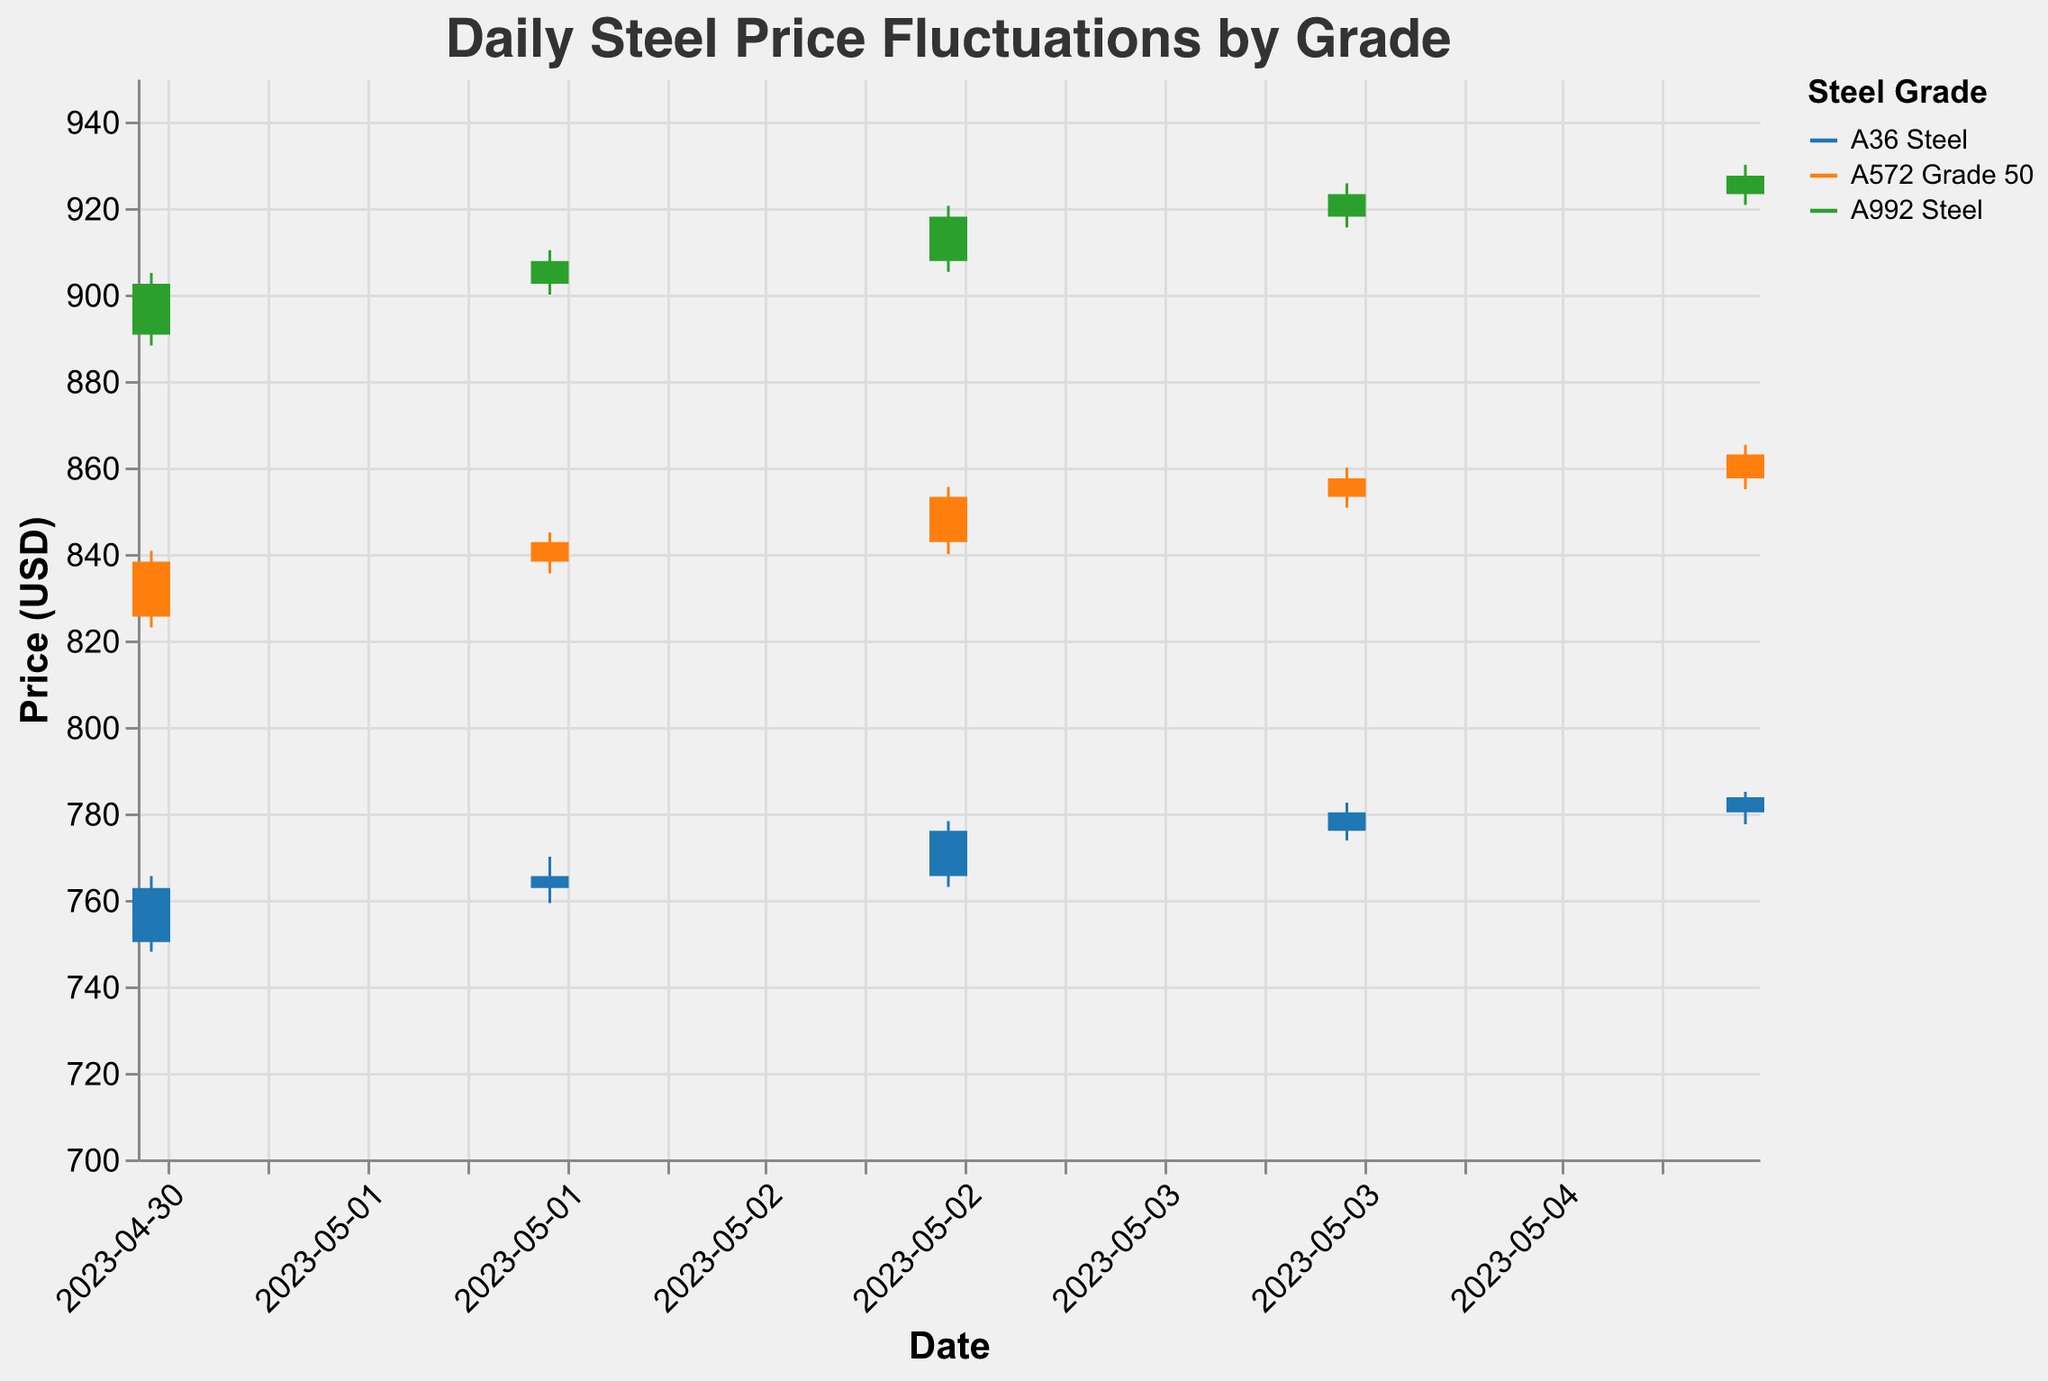What's the highest recorded price for A36 Steel? To find the highest recorded price for A36 Steel, we need to look at the "High" values for A36 Steel across all dates. The highest value for A36 Steel is 785.00 on May 05, 2023.
Answer: 785.00 Which grade of steel has the highest closing price on May 05, 2023? To find this, we need to compare the "Close" prices of all steel grades on May 05, 2023. For A36 Steel, it is 783.75; for A572 Grade 50, it is 863.00; and for A992 Steel, it is 927.50. The highest closing price is for A992 Steel.
Answer: A992 Steel What's the average closing price for A572 Grade 50 over the given dates? To find the average closing price, add the closing prices for A572 Grade 50 from May 01 to May 05: 838.25 + 842.75 + 853.25 + 857.50 + 863.00. Then, divide the sum by 5: (838.25 + 842.75 + 853.25 + 857.50 + 863.00) / 5 = 851.35
Answer: 851.35 Compare the opening price on May 01, 2023, to the closing price on May 05, 2023, for A36 Steel. Is it higher or lower? The opening price for A36 Steel on May 01, 2023, is 750.25, and the closing price on May 05, 2023, is 783.75. Since 783.75 is greater than 750.25, the closing price on May 05, 2023, is higher.
Answer: Higher Which day did A992 Steel have the smallest price fluctuation? To find the smallest fluctuation, we need to calculate the difference between the "High" and "Low" prices for each day for A992 Steel. The smallest difference is (910.25 - 900.00) = 10.25 on May 02, 2023.
Answer: May 02, 2023 What is the price range (high-low) for A572 Grade 50 on May 04, 2023? The price range for A572 Grade 50 on May 04, 2023, is the difference between the "High" and "Low" prices. The "High" price is 860.00 and the "Low" price is 850.75, so the range is 860.00 - 850.75 = 9.25
Answer: 9.25 Did any steel grade have a day where the closing price was lower than the opening price? To answer this, we examine each date for each grade and check if the closing price is less than the opening price:
- A36 Steel: All closing prices are higher than opening prices.
- A572 Grade 50: All closing prices are higher than opening prices.
- A992 Steel: All closing prices are higher than opening prices.
None of the steel grades had a day where the closing price was lower than the opening price.
Answer: No Across all grades, which day recorded the highest price given in the data? To find this, we need to check the "High" values for all grades and dates. The highest recorded price is for A992 Steel on May 05, 2023, with a "High" of 930.00.
Answer: May 05, 2023 